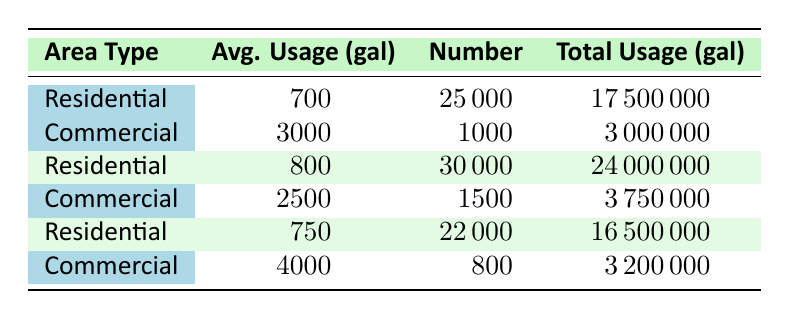What is the average usage per household in residential areas? The table shows an average usage of 700, 800, and 750 gallons per household across three residential data points. To find the overall average, we sum these values (700 + 800 + 750 = 2250) and divide by the number of data points (3), which gives us an average of 2250/3 = 750 gallons.
Answer: 750 What is the total water usage for commercial areas? The total water usage for commercial areas can be obtained by adding the total usages from all commercial data points: 3000000 + 3750000 + 3200000 = 9950000 gallons.
Answer: 9950000 Is the average water usage higher in residential areas compared to commercial areas? By checking the average residential values (700, 800, and 750) which average to 750, and the average commercial values (3000, 2500, 4000) which average to 3166.67, we see that 750 is less than 3166.67, so the statement is false.
Answer: No Which category has more total households/buildings? By examining the data, the residential area has a total of 25000 + 30000 + 22000 = 77000 households, while the commercial area has 1000 + 1500 + 800 = 3300 buildings. Since 77000 is significantly greater than 3300, residential areas have more households.
Answer: Residential What is the difference in total water usage between the highest residential usage and the lowest commercial usage? The highest total residential usage is 24000000 gallons and the lowest commercial usage is 3000000 gallons. The difference is calculated as 24000000 - 3000000 = 21000000 gallons. Therefore, the answer is 21000000.
Answer: 21000000 What is the average number of households in residential areas? The total number of households in residential areas is 25000 + 30000 + 22000 = 77000. To find the average, we divide by the number of residential entries, which is 3. Therefore, the average becomes 77000/3 = 25666.67, approximating to 25667 households.
Answer: 25667 Does the data show an increasing trend in average water usage per household in residential areas? To determine if there is an increase, we compare the average usage values: 700 → 800 → 750. The values do not consistently increase, since 800 is higher than both 700 and 750, thus, the trend cannot be classified as increasing.
Answer: No Which area type has the highest average water usage per unit? Calculating the averages, residential areas have averages of 700, 800, and 750 gallons, while commercial areas are 3000, 2500, and 4000 gallons. The highest average is 4000, which belongs to commercial areas.
Answer: Commercial 